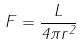<formula> <loc_0><loc_0><loc_500><loc_500>F = { \frac { L } { 4 \pi r ^ { 2 } } }</formula> 